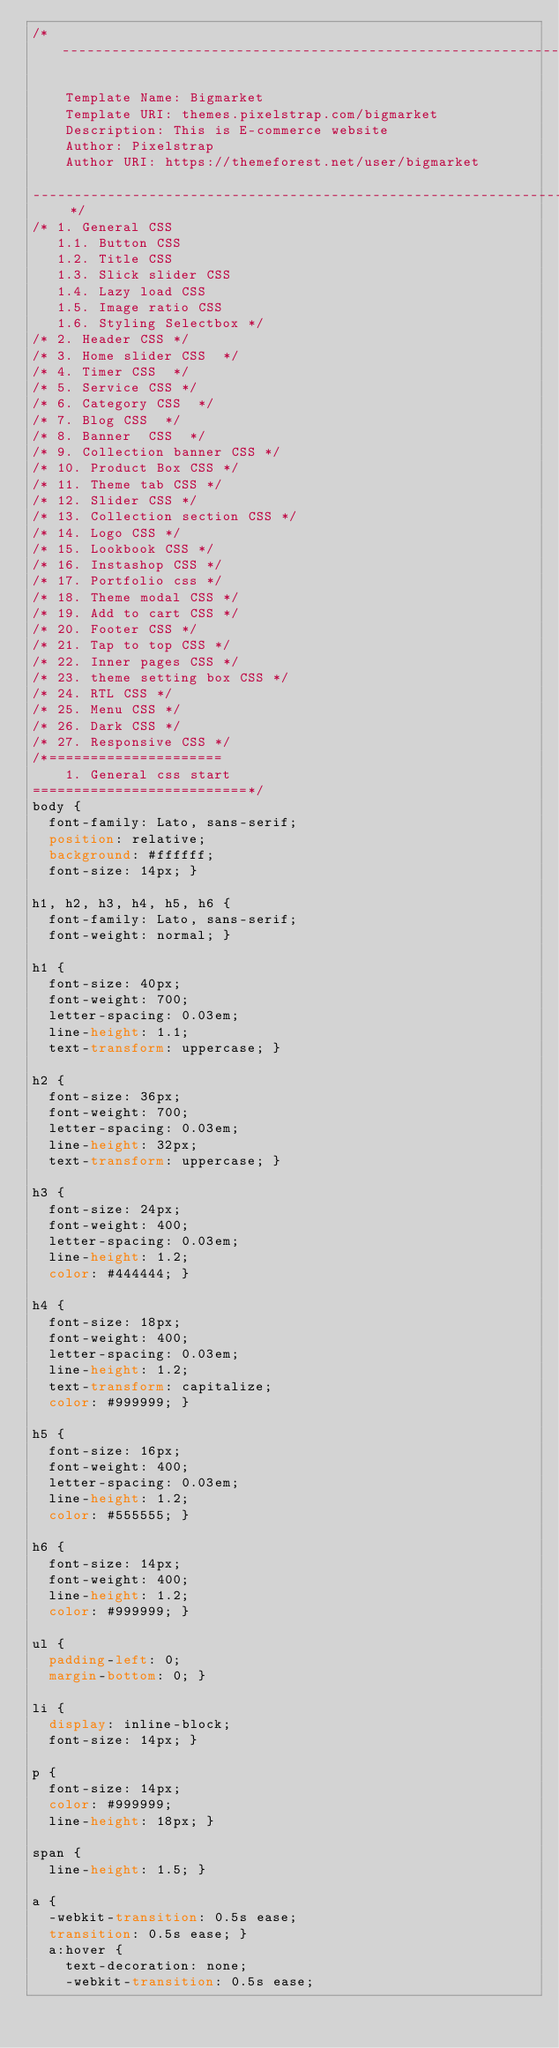<code> <loc_0><loc_0><loc_500><loc_500><_CSS_>/*-----------------------------------------------------------------------------------

    Template Name: Bigmarket
    Template URI: themes.pixelstrap.com/bigmarket
    Description: This is E-commerce website
    Author: Pixelstrap
    Author URI: https://themeforest.net/user/bigmarket

----------------------------------------------------------------------------------- */
/* 1. General CSS
   1.1. Button CSS
   1.2. Title CSS
   1.3. Slick slider CSS
   1.4. Lazy load CSS
   1.5. Image ratio CSS
   1.6. Styling Selectbox */
/* 2. Header CSS */
/* 3. Home slider CSS  */
/* 4. Timer CSS  */
/* 5. Service CSS */
/* 6. Category CSS  */
/* 7. Blog CSS  */
/* 8. Banner  CSS  */
/* 9. Collection banner CSS */
/* 10. Product Box CSS */
/* 11. Theme tab CSS */
/* 12. Slider CSS */
/* 13. Collection section CSS */
/* 14. Logo CSS */
/* 15. Lookbook CSS */
/* 16. Instashop CSS */
/* 17. Portfolio css */
/* 18. Theme modal CSS */
/* 19. Add to cart CSS */
/* 20. Footer CSS */
/* 21. Tap to top CSS */
/* 22. Inner pages CSS */
/* 23. theme setting box CSS */
/* 24. RTL CSS */
/* 25. Menu CSS */
/* 26. Dark CSS */
/* 27. Responsive CSS */
/*=====================
    1. General css start
==========================*/
body {
  font-family: Lato, sans-serif;
  position: relative;
  background: #ffffff;
  font-size: 14px; }

h1, h2, h3, h4, h5, h6 {
  font-family: Lato, sans-serif;
  font-weight: normal; }

h1 {
  font-size: 40px;
  font-weight: 700;
  letter-spacing: 0.03em;
  line-height: 1.1;
  text-transform: uppercase; }

h2 {
  font-size: 36px;
  font-weight: 700;
  letter-spacing: 0.03em;
  line-height: 32px;
  text-transform: uppercase; }

h3 {
  font-size: 24px;
  font-weight: 400;
  letter-spacing: 0.03em;
  line-height: 1.2;
  color: #444444; }

h4 {
  font-size: 18px;
  font-weight: 400;
  letter-spacing: 0.03em;
  line-height: 1.2;
  text-transform: capitalize;
  color: #999999; }

h5 {
  font-size: 16px;
  font-weight: 400;
  letter-spacing: 0.03em;
  line-height: 1.2;
  color: #555555; }

h6 {
  font-size: 14px;
  font-weight: 400;
  line-height: 1.2;
  color: #999999; }

ul {
  padding-left: 0;
  margin-bottom: 0; }

li {
  display: inline-block;
  font-size: 14px; }

p {
  font-size: 14px;
  color: #999999;
  line-height: 18px; }

span {
  line-height: 1.5; }

a {
  -webkit-transition: 0.5s ease;
  transition: 0.5s ease; }
  a:hover {
    text-decoration: none;
    -webkit-transition: 0.5s ease;</code> 